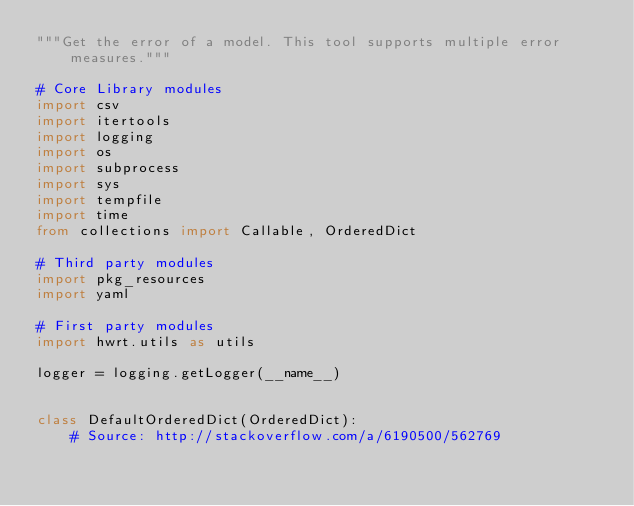<code> <loc_0><loc_0><loc_500><loc_500><_Python_>"""Get the error of a model. This tool supports multiple error measures."""

# Core Library modules
import csv
import itertools
import logging
import os
import subprocess
import sys
import tempfile
import time
from collections import Callable, OrderedDict

# Third party modules
import pkg_resources
import yaml

# First party modules
import hwrt.utils as utils

logger = logging.getLogger(__name__)


class DefaultOrderedDict(OrderedDict):
    # Source: http://stackoverflow.com/a/6190500/562769</code> 